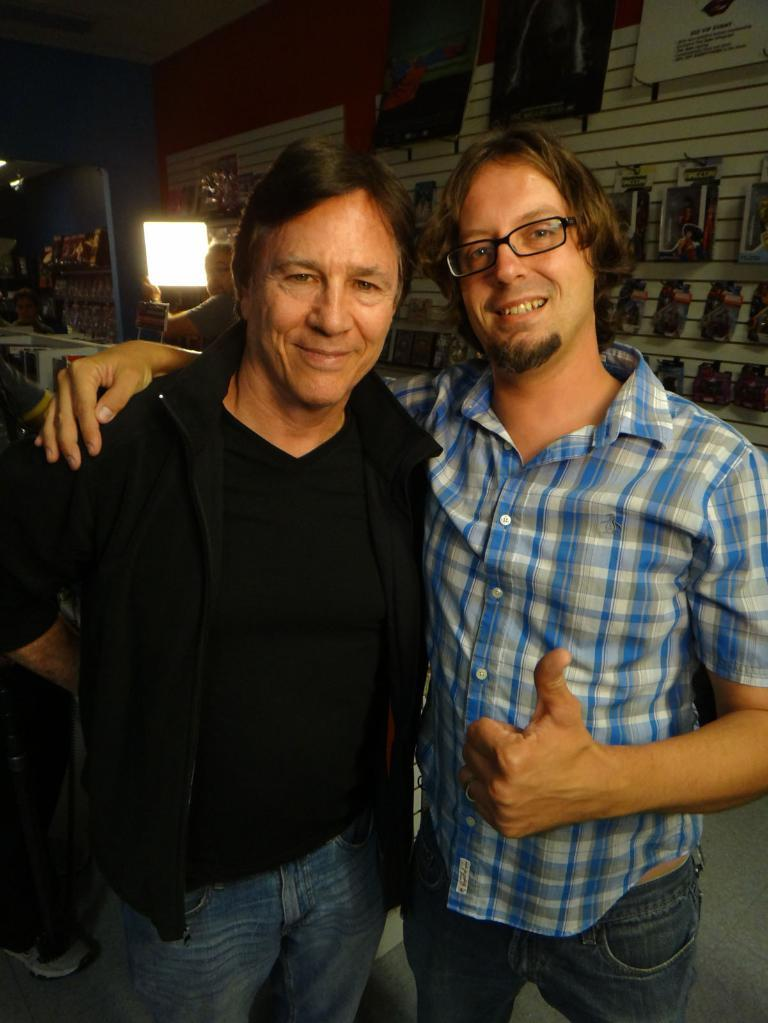How many people are present in the image? There are two persons standing in the image. What can be seen behind the persons? There is a wall visible behind the persons. What type of guide is helping the persons in the image? There is no guide present in the image, and the persons are not receiving any assistance. 